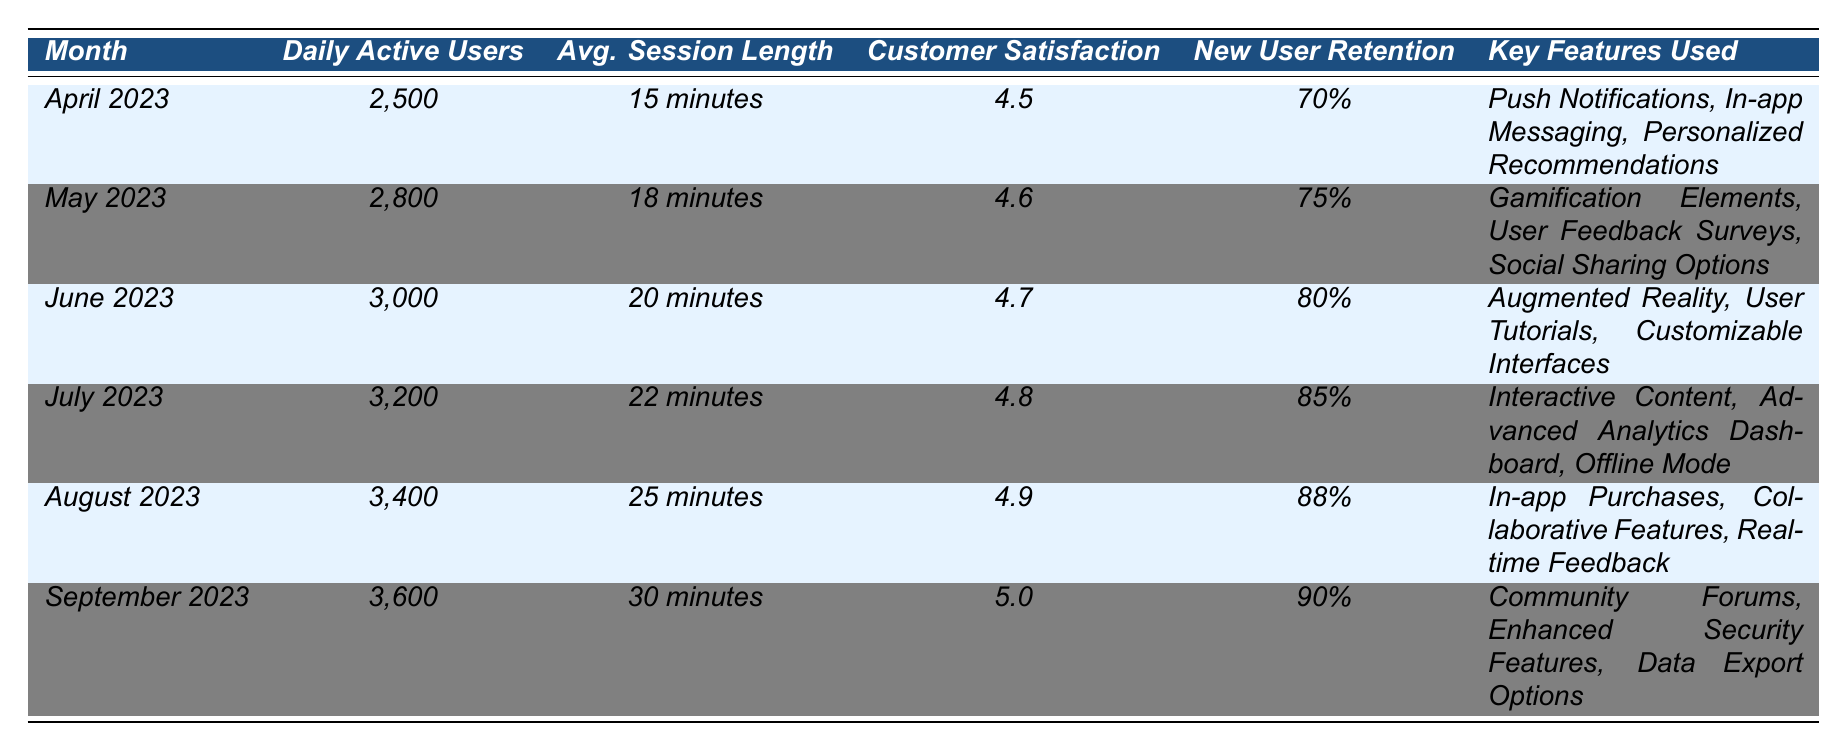What was the daily active users count in September 2023? The table shows that the daily active users for September 2023 is listed directly in the corresponding row.
Answer: 3600 What was the average session length in July 2023? The session length average for July 2023 is found in the table under that month's row.
Answer: 22 minutes Did the customer satisfaction score increase from April 2023 to August 2023? By comparing the scores from the respective months in the table, April's score (4.5) is less than August's score (4.9), indicating an increase.
Answer: Yes What was the percentage increase in daily active users from April 2023 to September 2023? The active users in April 2023 were 2500 and in September 2023 were 3600. The increase is (3600 - 2500) = 1100. The percentage increase is (1100 / 2500) * 100 = 44%.
Answer: 44% Which month had the highest customer satisfaction score? By reviewing the scores in the table, September 2023 has the highest score of 5.0.
Answer: September 2023 What was the average new user retention rate across all six months? To find the average retention rate, sum the percentages: 70% + 75% + 80% + 85% + 88% + 90% = 488%. Divide this by the number of months, which is 6: 488% / 6 = 81.33%.
Answer: 81.33% In which month did users engage with the most features simultaneously? The table shows that in September 2023, the features listed include three key features, as noted in the last column. This is the same for previous months, but features associated with user feedback and gamification may imply higher engagement dynamics. However, as per raw data comparison, all months listed three features.
Answer: Tie among all months 